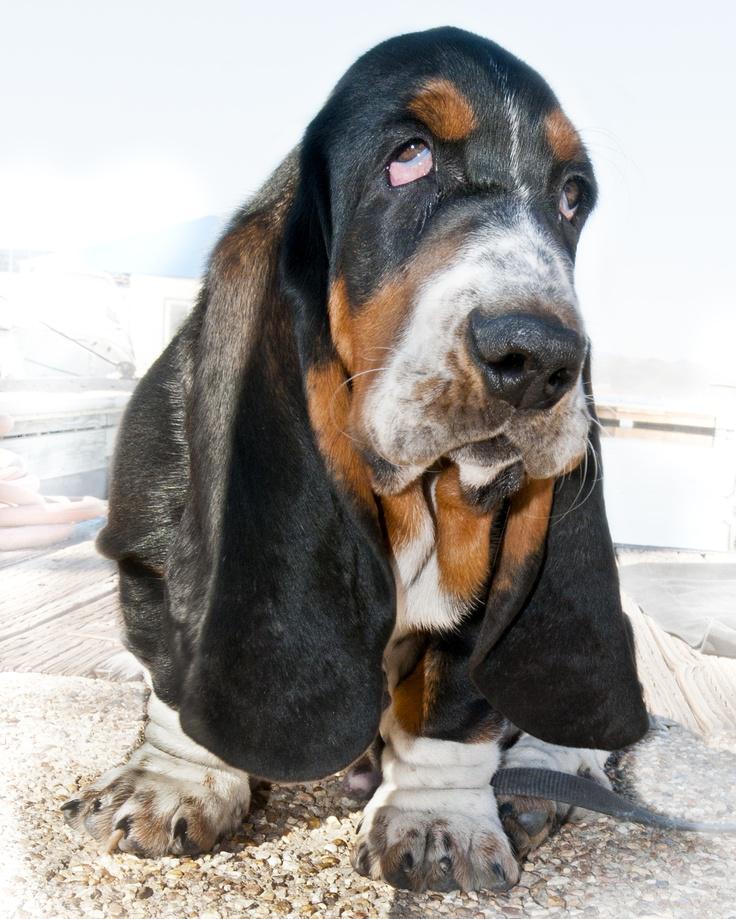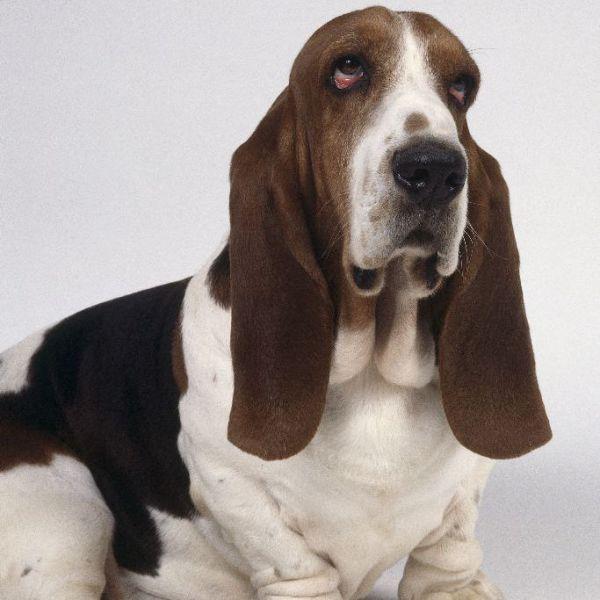The first image is the image on the left, the second image is the image on the right. For the images displayed, is the sentence "Each photo contains a single dog." factually correct? Answer yes or no. Yes. 